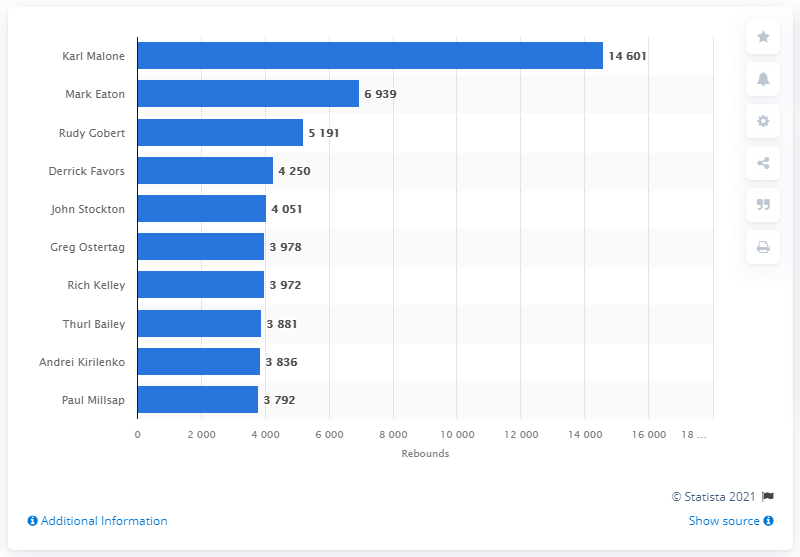Indicate a few pertinent items in this graphic. The career rebounds leader of the Utah Jazz is Karl Malone. 